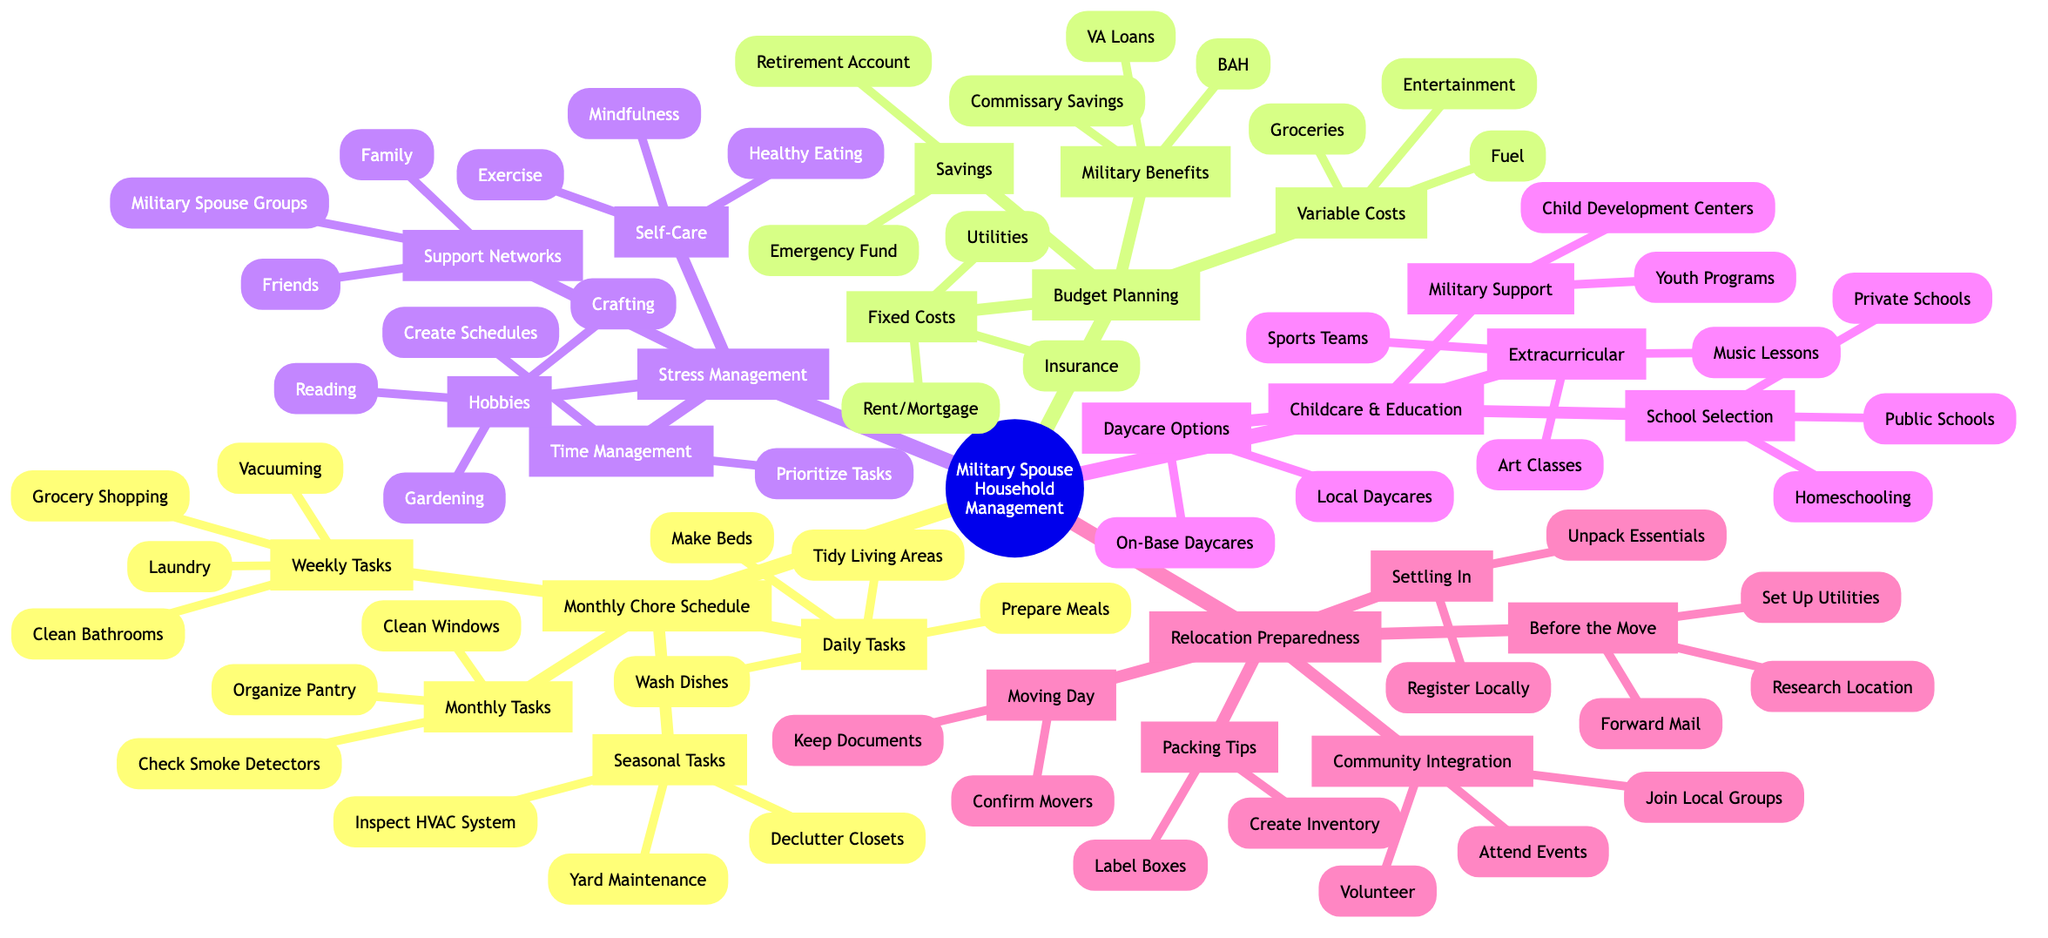What are some daily tasks listed in the mind map? The diagram explicitly lists the daily tasks under the "Monthly Household Chore Schedule" section. The tasks are "Make Beds," "Wash Dishes," "Tidy Living Areas," and "Prepare Meals."
Answer: Make Beds, Wash Dishes, Tidy Living Areas, Prepare Meals How many weekly tasks are listed? To find the number of weekly tasks, we can look under the "Weekly Tasks" branch in the "Monthly Household Chore Schedule" section, which shows there are four tasks: "Laundry," "Vacuuming," "Grocery Shopping," and "Clean Bathrooms."
Answer: 4 What is included in the budget category of variable costs? The variable costs are specifically defined in the "Budget Planning" branch. It consists of "Groceries," "Entertainment," "Fuel," and "Dining Out."
Answer: Groceries, Entertainment, Fuel, Dining Out Which self-care practice is mentioned in the stress management section? The stress management section contains a sub-branch labeled "Self-Care Practices," which includes maintaining "Exercise Regularly," "Healthy Eating," "Mindfulness," and "Adequate Sleep."
Answer: Exercise Regularly What are two types of daycare options available? Under the "Childcare and Educational Resources" branch, the sub-branch "Daycare Options" lists "On-Base Daycares," "Local Daycares," and "Family Childcare Providers." Two of these are "On-Base Daycares" and "Local Daycares."
Answer: On-Base Daycares, Local Daycares What strategies are listed for time management? The "Time Management" sub-branch includes three strategies: "Prioritize Tasks," "Create Schedules," and "Delegate Chores."
Answer: Prioritize Tasks, Create Schedules, Delegate Chores How many seasonal tasks are listed in the mind map? Moving to the "Seasonal Tasks" section under the "Monthly Household Chore Schedule" node, we can identify four tasks: "Inspect HVAC System," "Yard Maintenance," "Declutter Closets," and "Winterize Home."
Answer: 4 What is one packing tip mentioned for moving? The "Packing Tips" sub-branch presents strategies for effective packing, which includes "Label Boxes," "Create Inventory," and "Pack Essentials Separately." One example from this list is "Label Boxes."
Answer: Label Boxes 